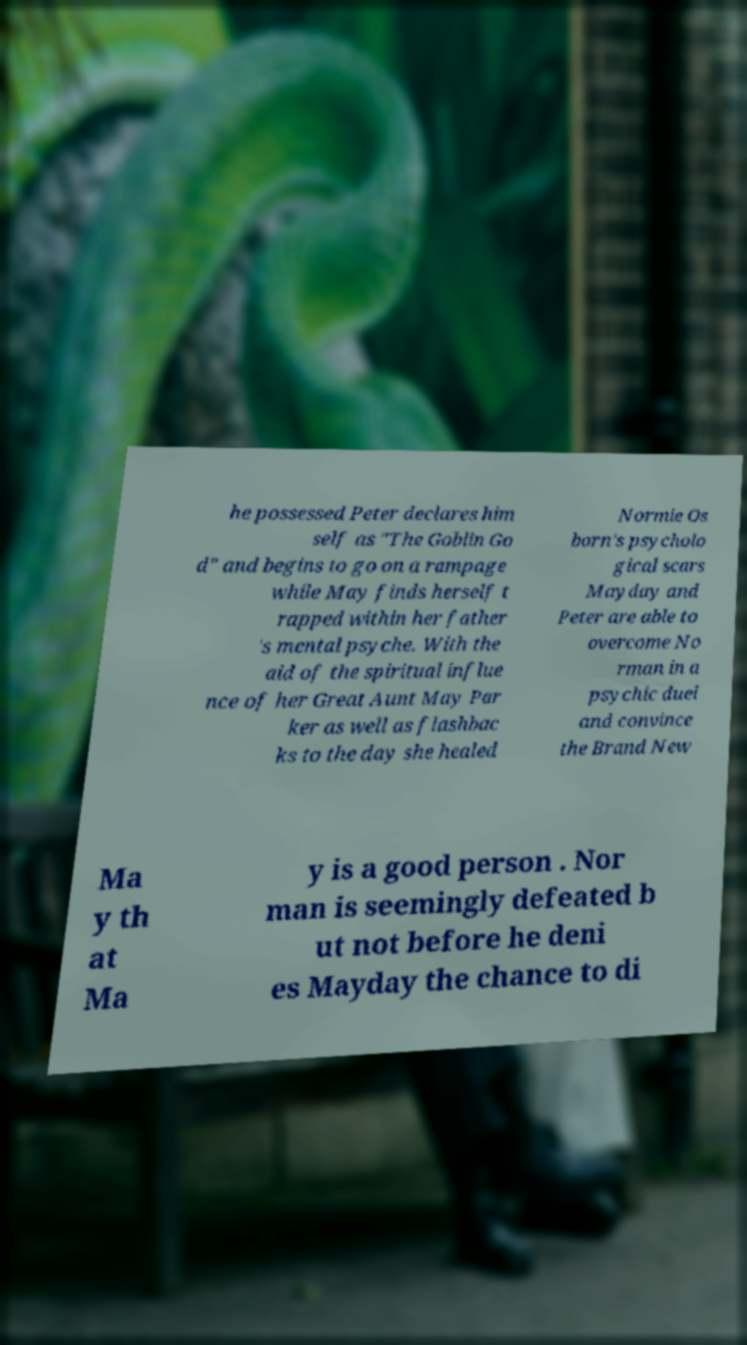Could you assist in decoding the text presented in this image and type it out clearly? he possessed Peter declares him self as "The Goblin Go d" and begins to go on a rampage while May finds herself t rapped within her father 's mental psyche. With the aid of the spiritual influe nce of her Great Aunt May Par ker as well as flashbac ks to the day she healed Normie Os born's psycholo gical scars Mayday and Peter are able to overcome No rman in a psychic duel and convince the Brand New Ma y th at Ma y is a good person . Nor man is seemingly defeated b ut not before he deni es Mayday the chance to di 